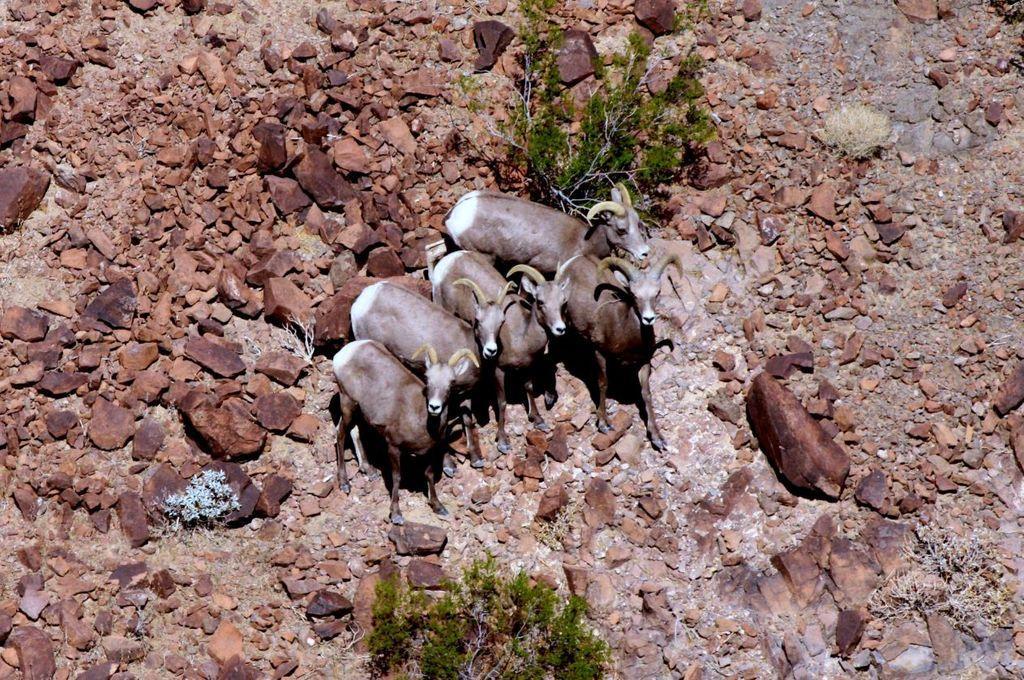Describe this image in one or two sentences. In this image, we can see animals, trees and rocks on the ground. 